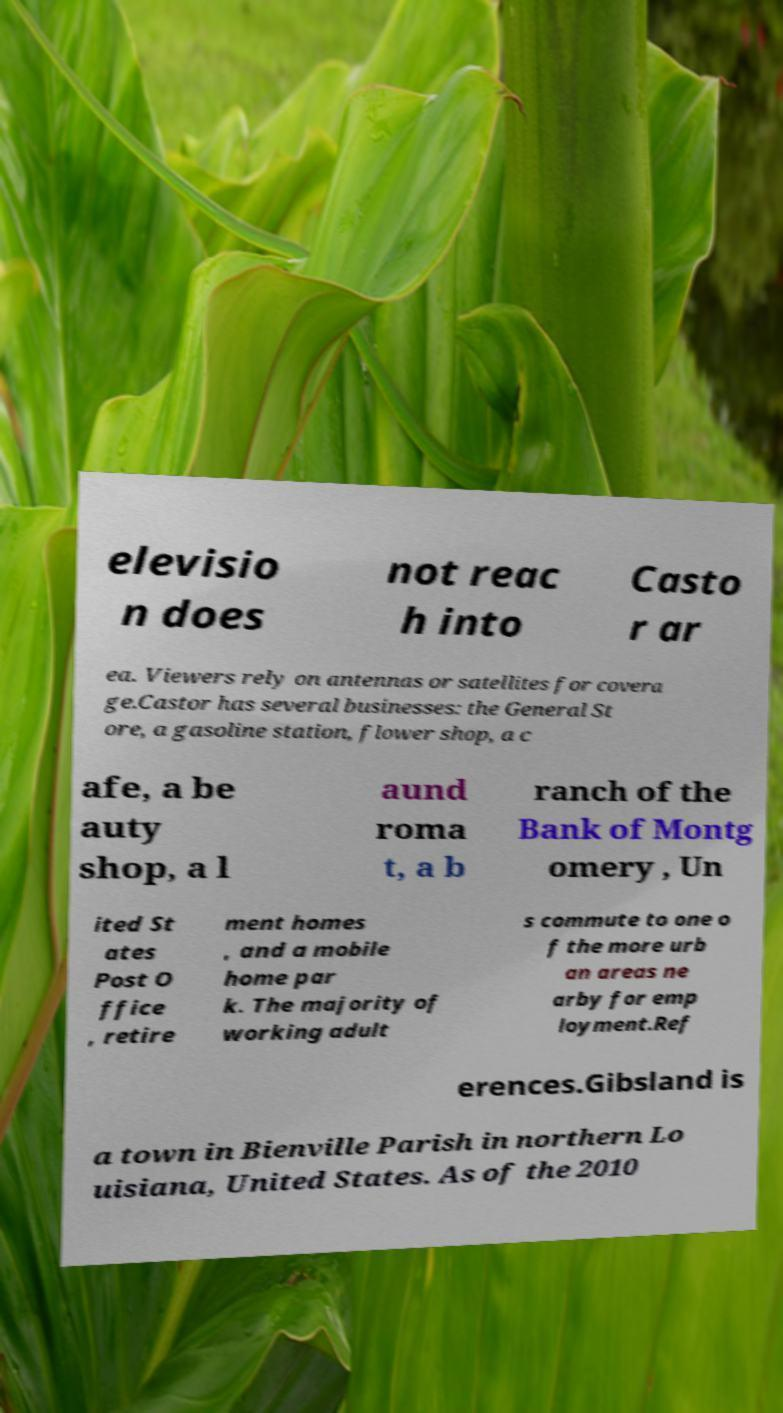There's text embedded in this image that I need extracted. Can you transcribe it verbatim? elevisio n does not reac h into Casto r ar ea. Viewers rely on antennas or satellites for covera ge.Castor has several businesses: the General St ore, a gasoline station, flower shop, a c afe, a be auty shop, a l aund roma t, a b ranch of the Bank of Montg omery , Un ited St ates Post O ffice , retire ment homes , and a mobile home par k. The majority of working adult s commute to one o f the more urb an areas ne arby for emp loyment.Ref erences.Gibsland is a town in Bienville Parish in northern Lo uisiana, United States. As of the 2010 